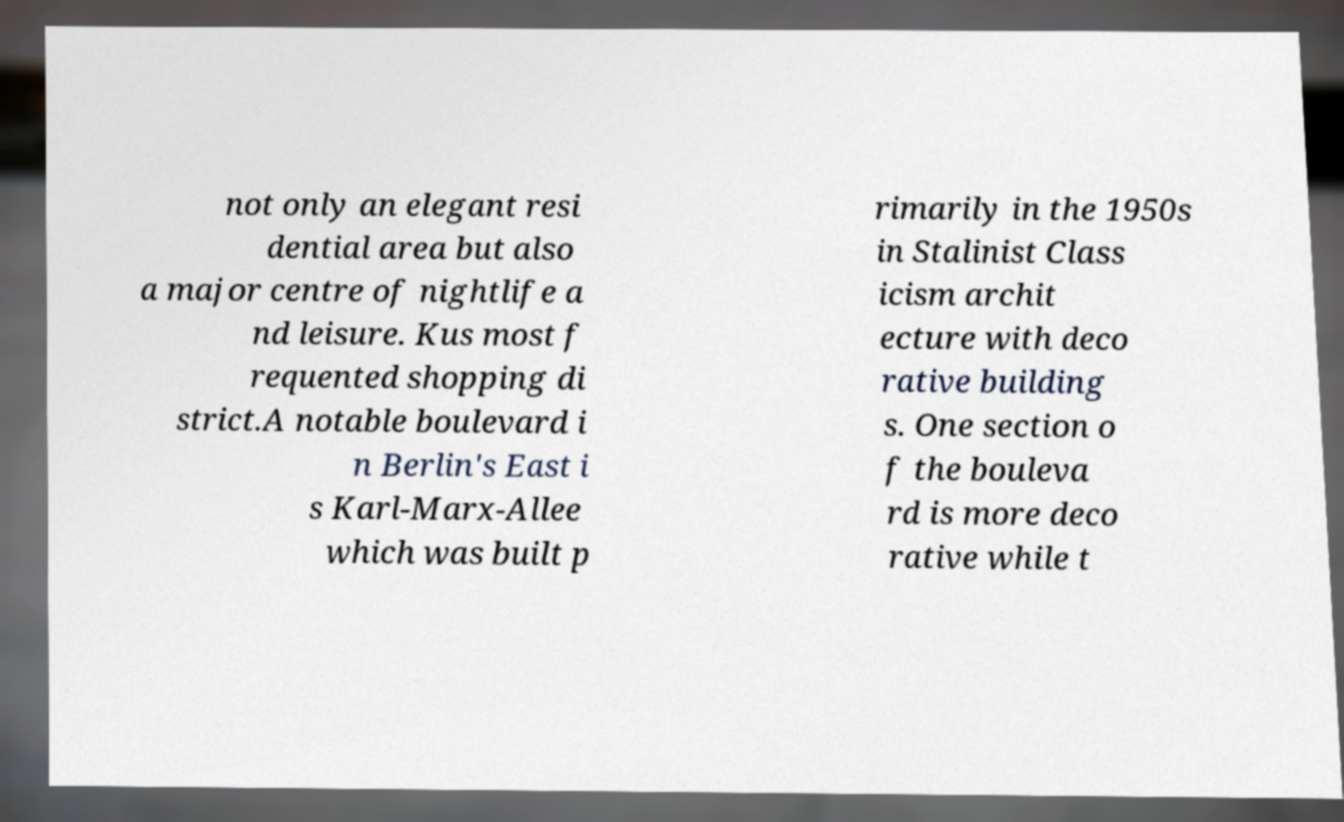What messages or text are displayed in this image? I need them in a readable, typed format. not only an elegant resi dential area but also a major centre of nightlife a nd leisure. Kus most f requented shopping di strict.A notable boulevard i n Berlin's East i s Karl-Marx-Allee which was built p rimarily in the 1950s in Stalinist Class icism archit ecture with deco rative building s. One section o f the bouleva rd is more deco rative while t 